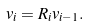Convert formula to latex. <formula><loc_0><loc_0><loc_500><loc_500>v _ { i } = R _ { i } v _ { i - 1 } .</formula> 